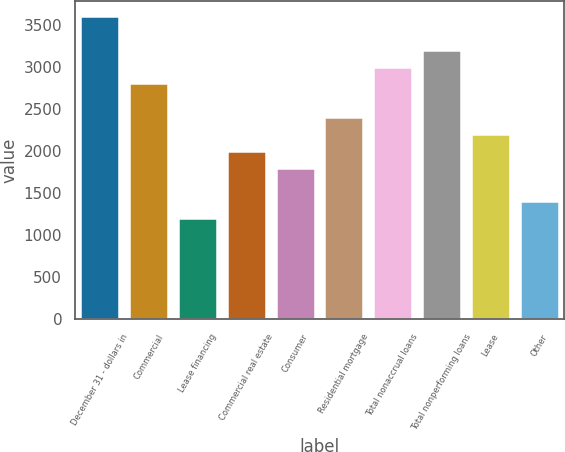Convert chart to OTSL. <chart><loc_0><loc_0><loc_500><loc_500><bar_chart><fcel>December 31 - dollars in<fcel>Commercial<fcel>Lease financing<fcel>Commercial real estate<fcel>Consumer<fcel>Residential mortgage<fcel>Total nonaccrual loans<fcel>Total nonperforming loans<fcel>Lease<fcel>Other<nl><fcel>3607.13<fcel>2805.57<fcel>1202.45<fcel>2004.01<fcel>1803.62<fcel>2404.79<fcel>3005.96<fcel>3206.35<fcel>2204.4<fcel>1402.84<nl></chart> 